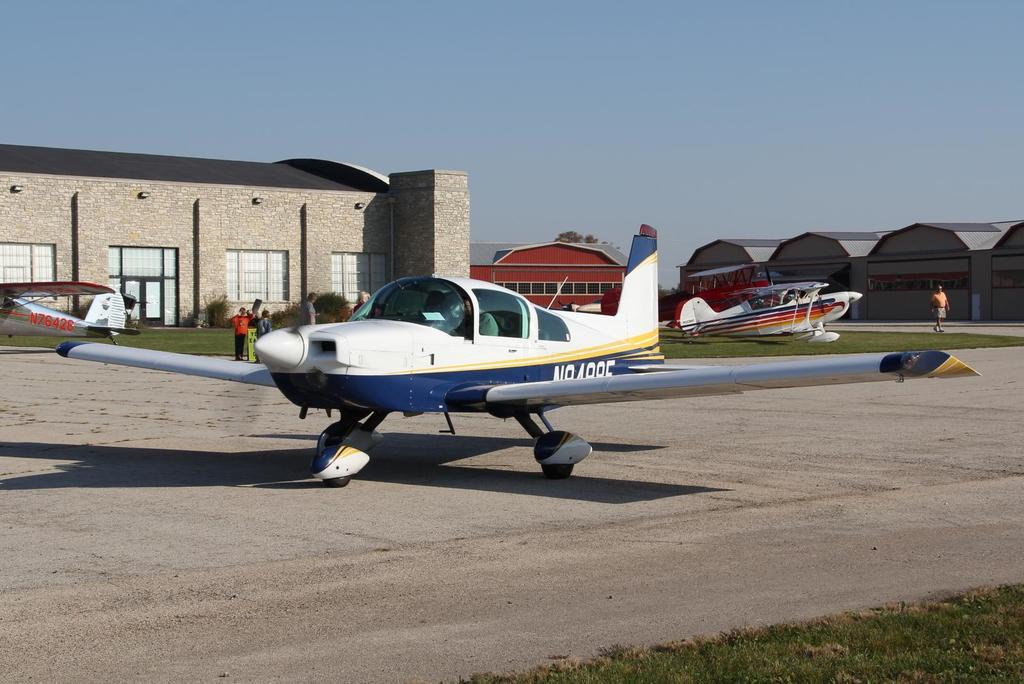<image>
Give a short and clear explanation of the subsequent image. a small plane that had AI94995 on the side of it 